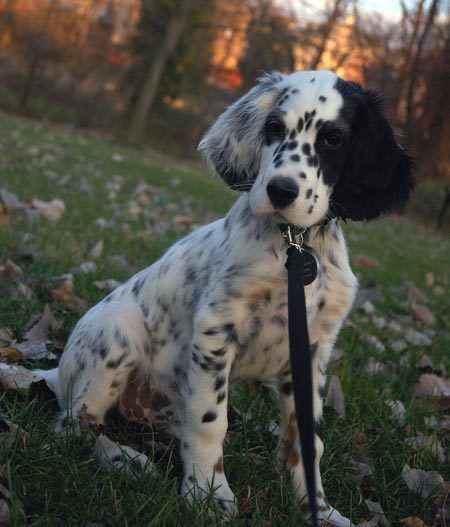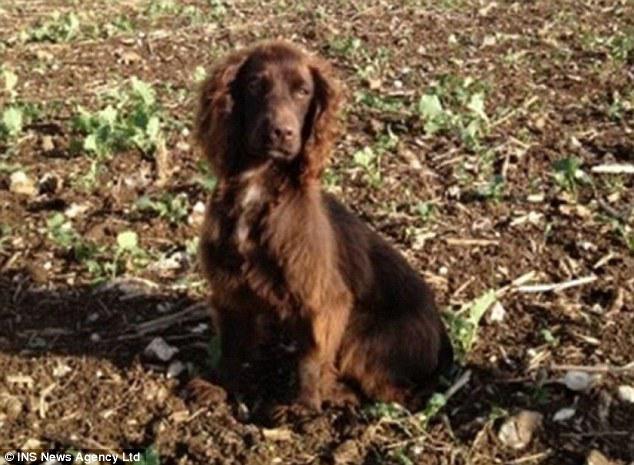The first image is the image on the left, the second image is the image on the right. Given the left and right images, does the statement "One of the dogs is white with black spots." hold true? Answer yes or no. Yes. 